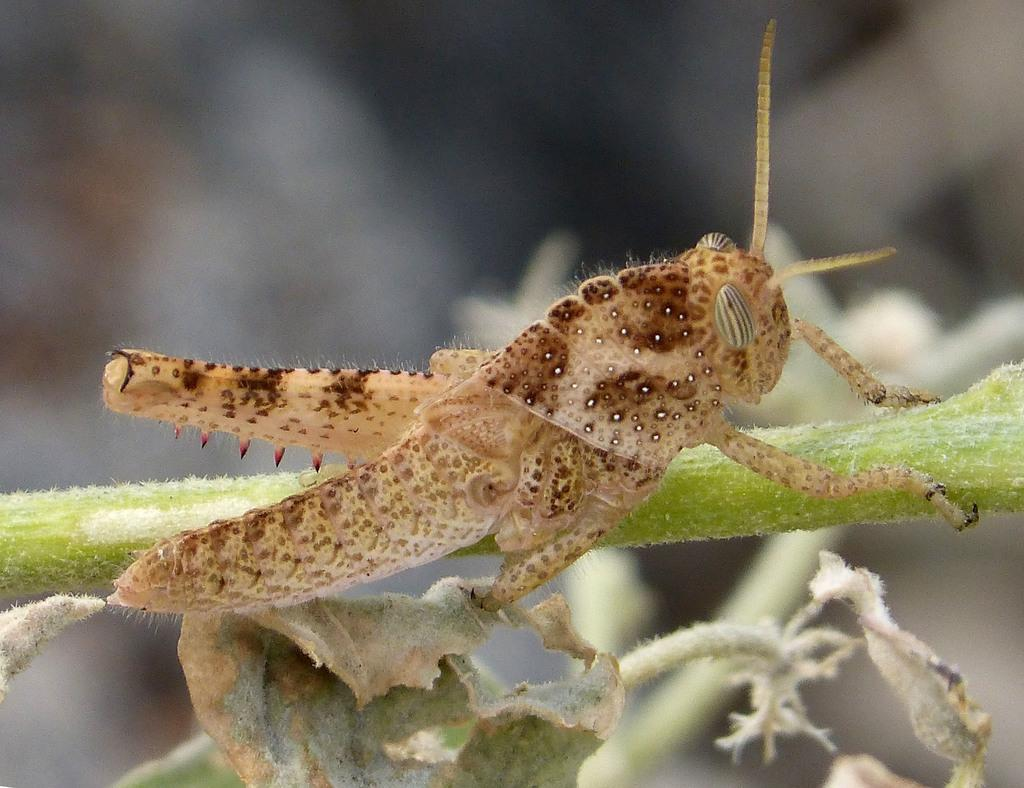What type of creature can be seen in the image? There is an insect in the image. Where is the insect located on the plant? The insect is on the stem of a plant. What type of chess piece is located on the faucet in the image? There is no chess piece or faucet present in the image; it features an insect on the stem of a plant. 